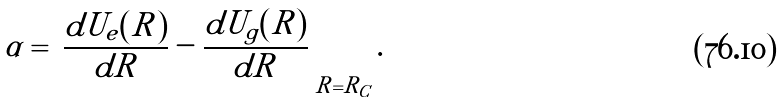<formula> <loc_0><loc_0><loc_500><loc_500>\alpha = \left | \frac { d U _ { e } ( R ) } { d R } - \frac { d U _ { g } ( R ) } { d R } \right | _ { R = R _ { C } } .</formula> 